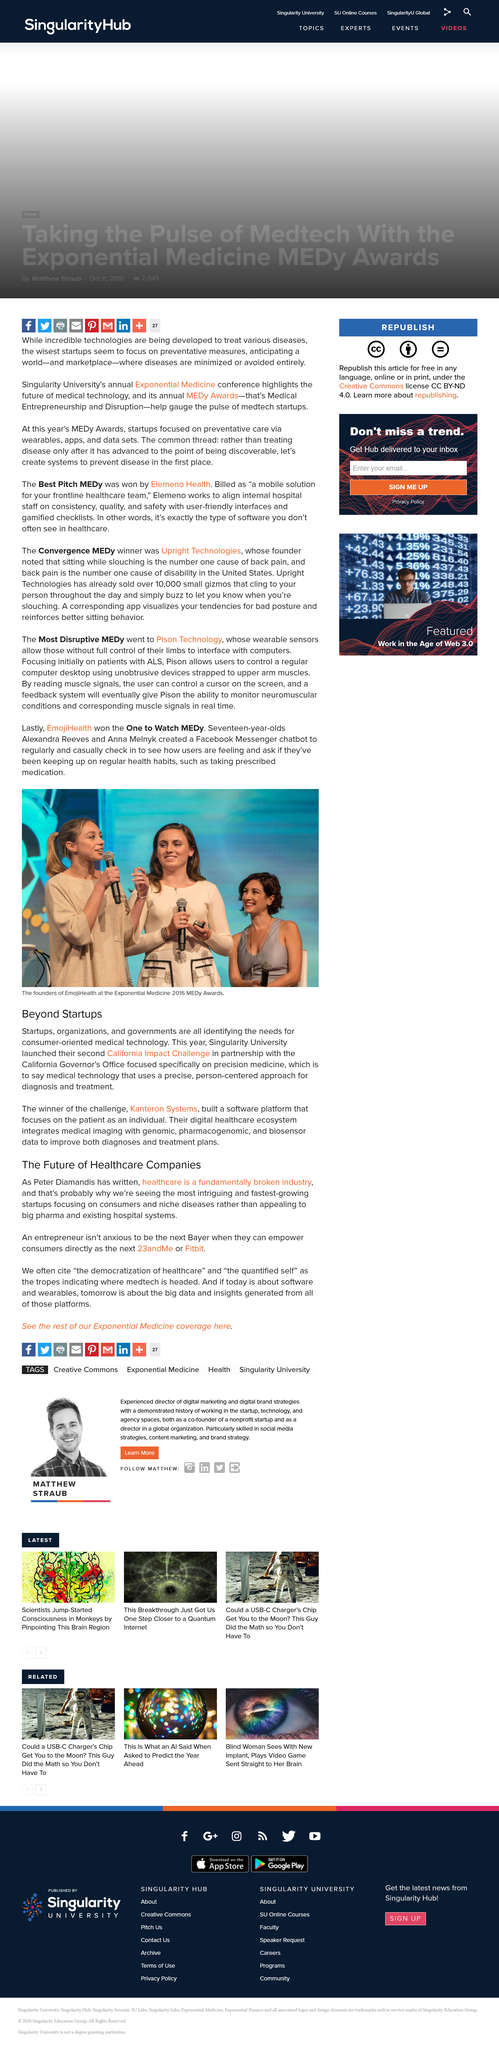Mention a couple of crucial points in this snapshot. The most intriguing and fastest growing startups are focusing on consumers and niche diseases. The democratization of healthcare and the quantified self are the tropes cited when indicating where medtech is headed. Singularity University launched the California Impact Challenge. Pison initially focused on treating patients with ALS, a type of motor neuron disease. Kanteron Systems' software platform is dedicated to focusing on the individual patient, providing a comprehensive and personalized approach to healthcare. 